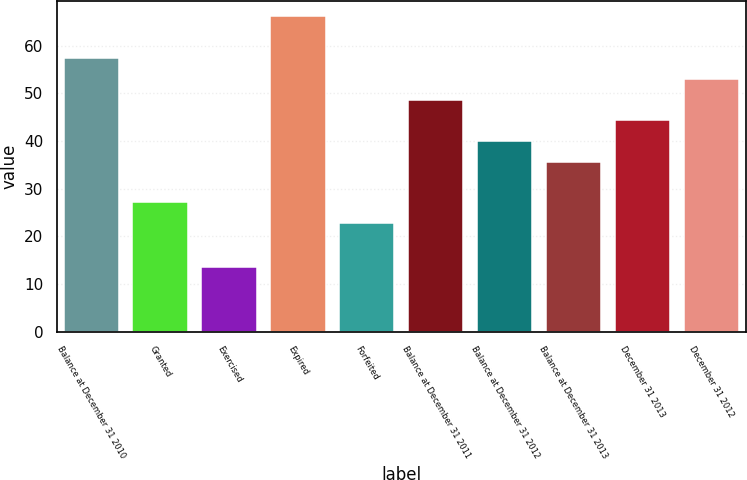Convert chart. <chart><loc_0><loc_0><loc_500><loc_500><bar_chart><fcel>Balance at December 31 2010<fcel>Granted<fcel>Exercised<fcel>Expired<fcel>Forfeited<fcel>Balance at December 31 2011<fcel>Balance at December 31 2012<fcel>Balance at December 31 2013<fcel>December 31 2013<fcel>December 31 2012<nl><fcel>57.39<fcel>27.11<fcel>13.6<fcel>66.13<fcel>22.74<fcel>48.65<fcel>39.91<fcel>35.54<fcel>44.28<fcel>53.02<nl></chart> 